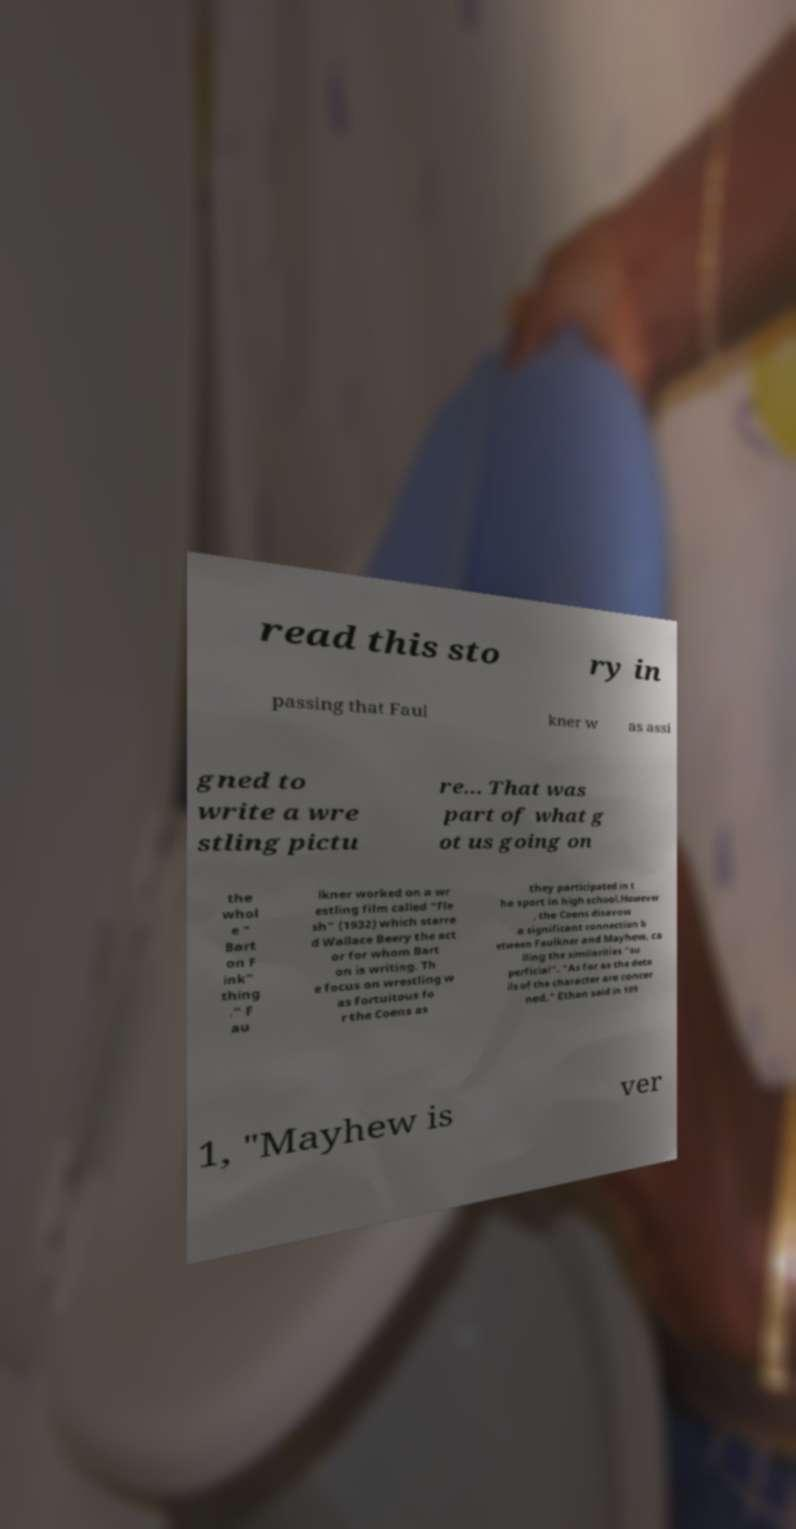Please read and relay the text visible in this image. What does it say? read this sto ry in passing that Faul kner w as assi gned to write a wre stling pictu re... That was part of what g ot us going on the whol e " Bart on F ink" thing ." F au lkner worked on a wr estling film called "Fle sh" (1932) which starre d Wallace Beery the act or for whom Bart on is writing. Th e focus on wrestling w as fortuitous fo r the Coens as they participated in t he sport in high school.However , the Coens disavow a significant connection b etween Faulkner and Mayhew, ca lling the similarities "su perficial". "As far as the deta ils of the character are concer ned," Ethan said in 199 1, "Mayhew is ver 